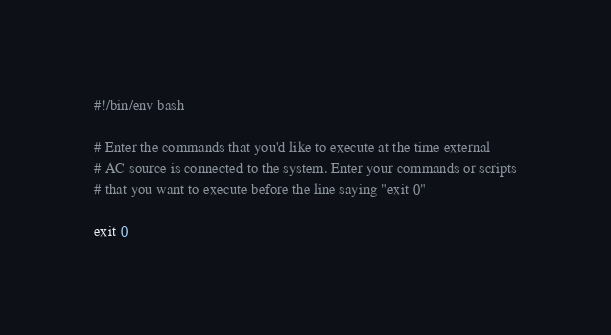Convert code to text. <code><loc_0><loc_0><loc_500><loc_500><_Bash_>#!/bin/env bash

# Enter the commands that you'd like to execute at the time external
# AC source is connected to the system. Enter your commands or scripts
# that you want to execute before the line saying "exit 0"

exit 0
</code> 